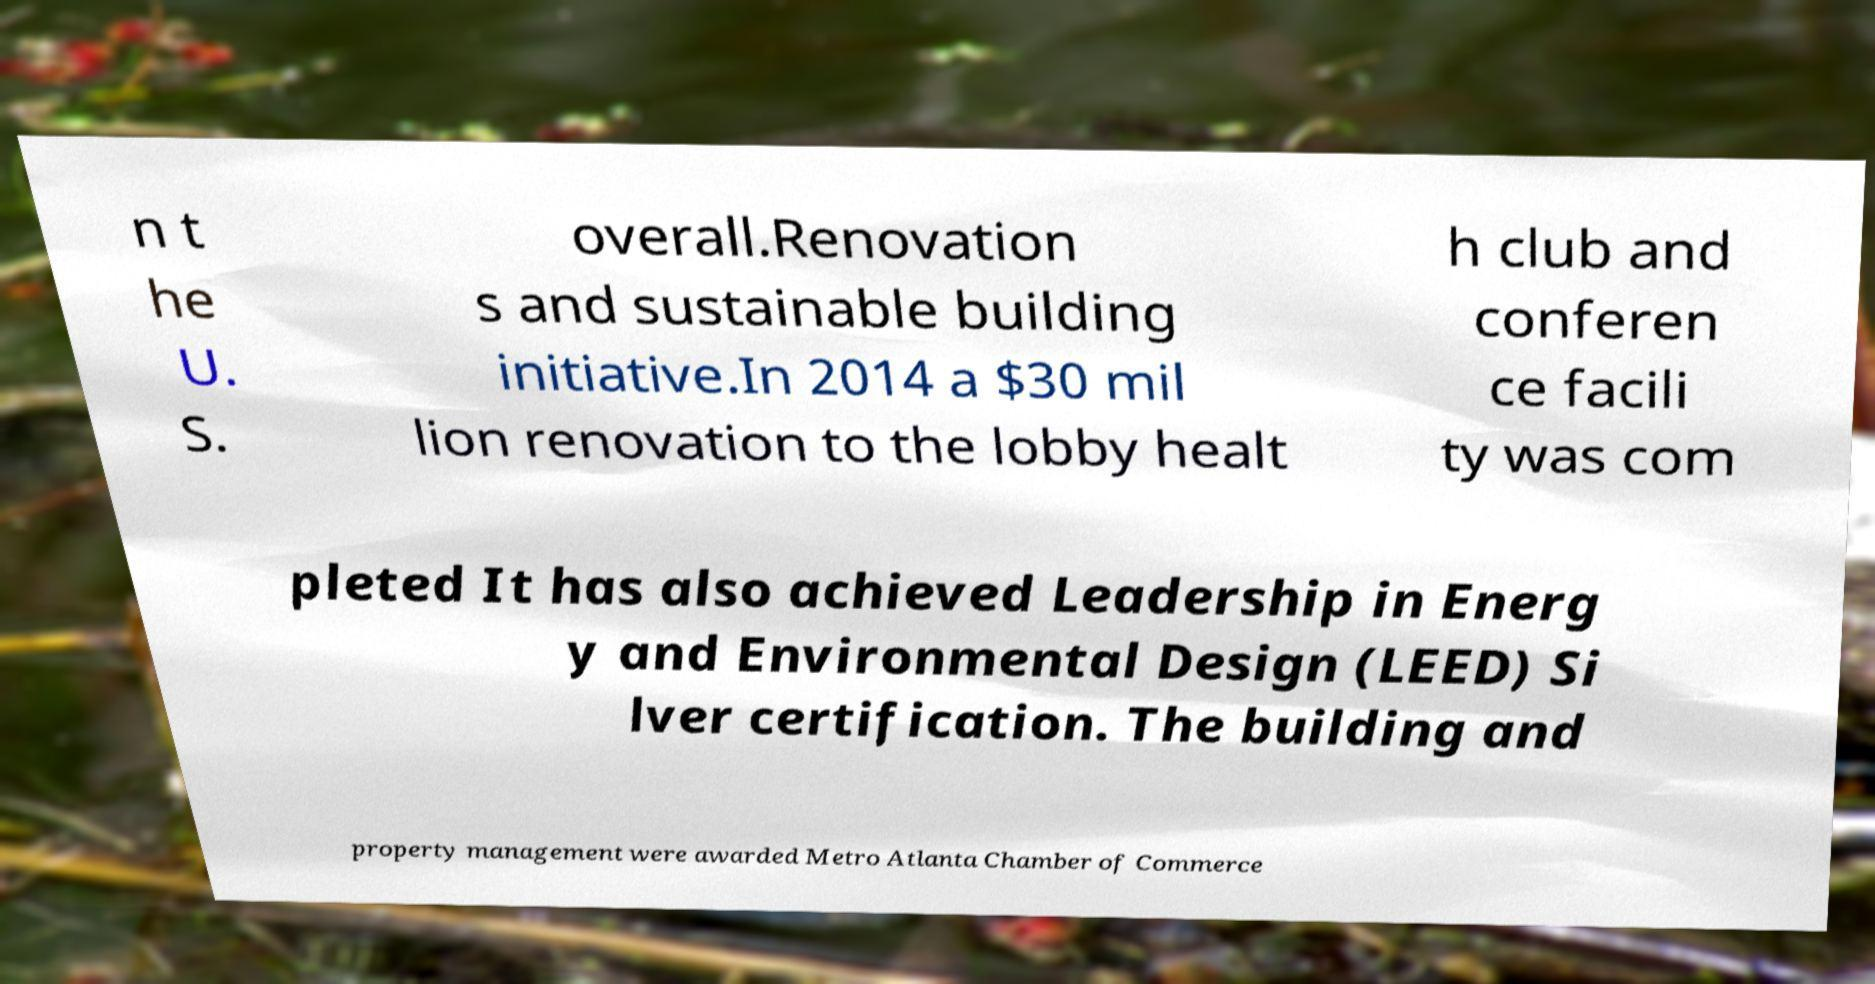For documentation purposes, I need the text within this image transcribed. Could you provide that? n t he U. S. overall.Renovation s and sustainable building initiative.In 2014 a $30 mil lion renovation to the lobby healt h club and conferen ce facili ty was com pleted It has also achieved Leadership in Energ y and Environmental Design (LEED) Si lver certification. The building and property management were awarded Metro Atlanta Chamber of Commerce 